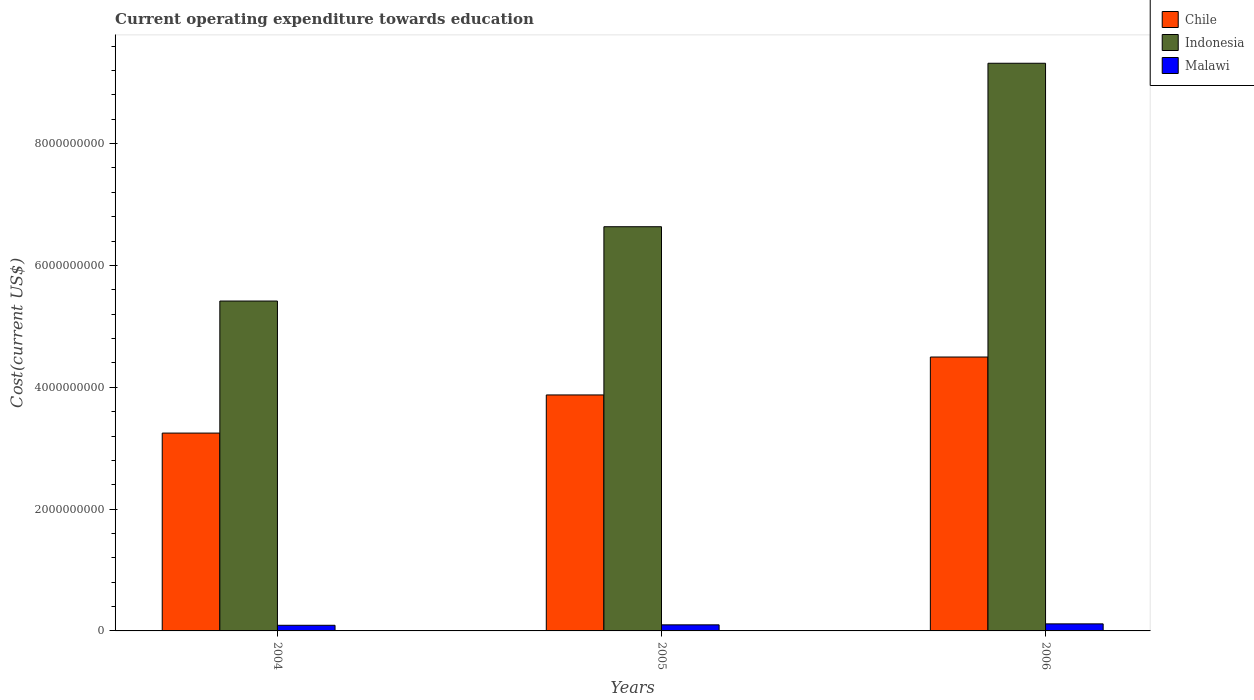How many different coloured bars are there?
Provide a short and direct response. 3. Are the number of bars per tick equal to the number of legend labels?
Provide a short and direct response. Yes. Are the number of bars on each tick of the X-axis equal?
Give a very brief answer. Yes. How many bars are there on the 1st tick from the left?
Keep it short and to the point. 3. What is the label of the 3rd group of bars from the left?
Give a very brief answer. 2006. What is the expenditure towards education in Malawi in 2004?
Ensure brevity in your answer.  9.25e+07. Across all years, what is the maximum expenditure towards education in Chile?
Make the answer very short. 4.50e+09. Across all years, what is the minimum expenditure towards education in Indonesia?
Your answer should be compact. 5.42e+09. In which year was the expenditure towards education in Malawi maximum?
Your answer should be very brief. 2006. In which year was the expenditure towards education in Indonesia minimum?
Keep it short and to the point. 2004. What is the total expenditure towards education in Indonesia in the graph?
Give a very brief answer. 2.14e+1. What is the difference between the expenditure towards education in Malawi in 2004 and that in 2005?
Provide a short and direct response. -7.20e+06. What is the difference between the expenditure towards education in Malawi in 2005 and the expenditure towards education in Chile in 2004?
Your response must be concise. -3.15e+09. What is the average expenditure towards education in Indonesia per year?
Offer a very short reply. 7.12e+09. In the year 2005, what is the difference between the expenditure towards education in Malawi and expenditure towards education in Indonesia?
Ensure brevity in your answer.  -6.54e+09. In how many years, is the expenditure towards education in Indonesia greater than 4800000000 US$?
Give a very brief answer. 3. What is the ratio of the expenditure towards education in Malawi in 2004 to that in 2006?
Ensure brevity in your answer.  0.8. Is the expenditure towards education in Indonesia in 2005 less than that in 2006?
Provide a short and direct response. Yes. What is the difference between the highest and the second highest expenditure towards education in Chile?
Provide a succinct answer. 6.22e+08. What is the difference between the highest and the lowest expenditure towards education in Chile?
Offer a terse response. 1.25e+09. In how many years, is the expenditure towards education in Indonesia greater than the average expenditure towards education in Indonesia taken over all years?
Make the answer very short. 1. Is the sum of the expenditure towards education in Chile in 2005 and 2006 greater than the maximum expenditure towards education in Malawi across all years?
Provide a succinct answer. Yes. What does the 3rd bar from the left in 2004 represents?
Your answer should be compact. Malawi. What does the 3rd bar from the right in 2006 represents?
Ensure brevity in your answer.  Chile. Are all the bars in the graph horizontal?
Offer a terse response. No. What is the difference between two consecutive major ticks on the Y-axis?
Give a very brief answer. 2.00e+09. Are the values on the major ticks of Y-axis written in scientific E-notation?
Ensure brevity in your answer.  No. Does the graph contain any zero values?
Offer a very short reply. No. Where does the legend appear in the graph?
Give a very brief answer. Top right. How are the legend labels stacked?
Give a very brief answer. Vertical. What is the title of the graph?
Offer a very short reply. Current operating expenditure towards education. Does "Argentina" appear as one of the legend labels in the graph?
Your response must be concise. No. What is the label or title of the X-axis?
Offer a very short reply. Years. What is the label or title of the Y-axis?
Your response must be concise. Cost(current US$). What is the Cost(current US$) of Chile in 2004?
Provide a succinct answer. 3.25e+09. What is the Cost(current US$) of Indonesia in 2004?
Keep it short and to the point. 5.42e+09. What is the Cost(current US$) of Malawi in 2004?
Your answer should be compact. 9.25e+07. What is the Cost(current US$) of Chile in 2005?
Make the answer very short. 3.87e+09. What is the Cost(current US$) of Indonesia in 2005?
Your response must be concise. 6.64e+09. What is the Cost(current US$) in Malawi in 2005?
Provide a short and direct response. 9.97e+07. What is the Cost(current US$) in Chile in 2006?
Make the answer very short. 4.50e+09. What is the Cost(current US$) of Indonesia in 2006?
Offer a terse response. 9.32e+09. What is the Cost(current US$) in Malawi in 2006?
Ensure brevity in your answer.  1.16e+08. Across all years, what is the maximum Cost(current US$) in Chile?
Your answer should be compact. 4.50e+09. Across all years, what is the maximum Cost(current US$) in Indonesia?
Keep it short and to the point. 9.32e+09. Across all years, what is the maximum Cost(current US$) in Malawi?
Offer a terse response. 1.16e+08. Across all years, what is the minimum Cost(current US$) of Chile?
Keep it short and to the point. 3.25e+09. Across all years, what is the minimum Cost(current US$) in Indonesia?
Provide a succinct answer. 5.42e+09. Across all years, what is the minimum Cost(current US$) in Malawi?
Your answer should be very brief. 9.25e+07. What is the total Cost(current US$) in Chile in the graph?
Your answer should be compact. 1.16e+1. What is the total Cost(current US$) of Indonesia in the graph?
Ensure brevity in your answer.  2.14e+1. What is the total Cost(current US$) in Malawi in the graph?
Your response must be concise. 3.08e+08. What is the difference between the Cost(current US$) of Chile in 2004 and that in 2005?
Offer a very short reply. -6.26e+08. What is the difference between the Cost(current US$) in Indonesia in 2004 and that in 2005?
Keep it short and to the point. -1.22e+09. What is the difference between the Cost(current US$) in Malawi in 2004 and that in 2005?
Give a very brief answer. -7.20e+06. What is the difference between the Cost(current US$) of Chile in 2004 and that in 2006?
Keep it short and to the point. -1.25e+09. What is the difference between the Cost(current US$) of Indonesia in 2004 and that in 2006?
Offer a terse response. -3.90e+09. What is the difference between the Cost(current US$) of Malawi in 2004 and that in 2006?
Your answer should be very brief. -2.32e+07. What is the difference between the Cost(current US$) of Chile in 2005 and that in 2006?
Your answer should be compact. -6.22e+08. What is the difference between the Cost(current US$) of Indonesia in 2005 and that in 2006?
Ensure brevity in your answer.  -2.68e+09. What is the difference between the Cost(current US$) in Malawi in 2005 and that in 2006?
Make the answer very short. -1.60e+07. What is the difference between the Cost(current US$) in Chile in 2004 and the Cost(current US$) in Indonesia in 2005?
Offer a terse response. -3.39e+09. What is the difference between the Cost(current US$) in Chile in 2004 and the Cost(current US$) in Malawi in 2005?
Offer a terse response. 3.15e+09. What is the difference between the Cost(current US$) of Indonesia in 2004 and the Cost(current US$) of Malawi in 2005?
Offer a very short reply. 5.32e+09. What is the difference between the Cost(current US$) in Chile in 2004 and the Cost(current US$) in Indonesia in 2006?
Provide a short and direct response. -6.07e+09. What is the difference between the Cost(current US$) of Chile in 2004 and the Cost(current US$) of Malawi in 2006?
Ensure brevity in your answer.  3.13e+09. What is the difference between the Cost(current US$) of Indonesia in 2004 and the Cost(current US$) of Malawi in 2006?
Keep it short and to the point. 5.30e+09. What is the difference between the Cost(current US$) of Chile in 2005 and the Cost(current US$) of Indonesia in 2006?
Your answer should be very brief. -5.45e+09. What is the difference between the Cost(current US$) in Chile in 2005 and the Cost(current US$) in Malawi in 2006?
Your answer should be very brief. 3.76e+09. What is the difference between the Cost(current US$) in Indonesia in 2005 and the Cost(current US$) in Malawi in 2006?
Your answer should be very brief. 6.52e+09. What is the average Cost(current US$) in Chile per year?
Your response must be concise. 3.87e+09. What is the average Cost(current US$) of Indonesia per year?
Your answer should be compact. 7.12e+09. What is the average Cost(current US$) of Malawi per year?
Provide a short and direct response. 1.03e+08. In the year 2004, what is the difference between the Cost(current US$) of Chile and Cost(current US$) of Indonesia?
Provide a succinct answer. -2.17e+09. In the year 2004, what is the difference between the Cost(current US$) of Chile and Cost(current US$) of Malawi?
Give a very brief answer. 3.16e+09. In the year 2004, what is the difference between the Cost(current US$) in Indonesia and Cost(current US$) in Malawi?
Your response must be concise. 5.32e+09. In the year 2005, what is the difference between the Cost(current US$) in Chile and Cost(current US$) in Indonesia?
Make the answer very short. -2.76e+09. In the year 2005, what is the difference between the Cost(current US$) of Chile and Cost(current US$) of Malawi?
Offer a terse response. 3.77e+09. In the year 2005, what is the difference between the Cost(current US$) in Indonesia and Cost(current US$) in Malawi?
Keep it short and to the point. 6.54e+09. In the year 2006, what is the difference between the Cost(current US$) of Chile and Cost(current US$) of Indonesia?
Ensure brevity in your answer.  -4.82e+09. In the year 2006, what is the difference between the Cost(current US$) in Chile and Cost(current US$) in Malawi?
Offer a terse response. 4.38e+09. In the year 2006, what is the difference between the Cost(current US$) in Indonesia and Cost(current US$) in Malawi?
Your answer should be very brief. 9.20e+09. What is the ratio of the Cost(current US$) in Chile in 2004 to that in 2005?
Ensure brevity in your answer.  0.84. What is the ratio of the Cost(current US$) of Indonesia in 2004 to that in 2005?
Keep it short and to the point. 0.82. What is the ratio of the Cost(current US$) of Malawi in 2004 to that in 2005?
Provide a succinct answer. 0.93. What is the ratio of the Cost(current US$) in Chile in 2004 to that in 2006?
Your response must be concise. 0.72. What is the ratio of the Cost(current US$) in Indonesia in 2004 to that in 2006?
Make the answer very short. 0.58. What is the ratio of the Cost(current US$) in Malawi in 2004 to that in 2006?
Your answer should be compact. 0.8. What is the ratio of the Cost(current US$) in Chile in 2005 to that in 2006?
Ensure brevity in your answer.  0.86. What is the ratio of the Cost(current US$) in Indonesia in 2005 to that in 2006?
Ensure brevity in your answer.  0.71. What is the ratio of the Cost(current US$) in Malawi in 2005 to that in 2006?
Provide a short and direct response. 0.86. What is the difference between the highest and the second highest Cost(current US$) of Chile?
Your response must be concise. 6.22e+08. What is the difference between the highest and the second highest Cost(current US$) in Indonesia?
Make the answer very short. 2.68e+09. What is the difference between the highest and the second highest Cost(current US$) of Malawi?
Ensure brevity in your answer.  1.60e+07. What is the difference between the highest and the lowest Cost(current US$) of Chile?
Provide a short and direct response. 1.25e+09. What is the difference between the highest and the lowest Cost(current US$) of Indonesia?
Your response must be concise. 3.90e+09. What is the difference between the highest and the lowest Cost(current US$) of Malawi?
Offer a terse response. 2.32e+07. 